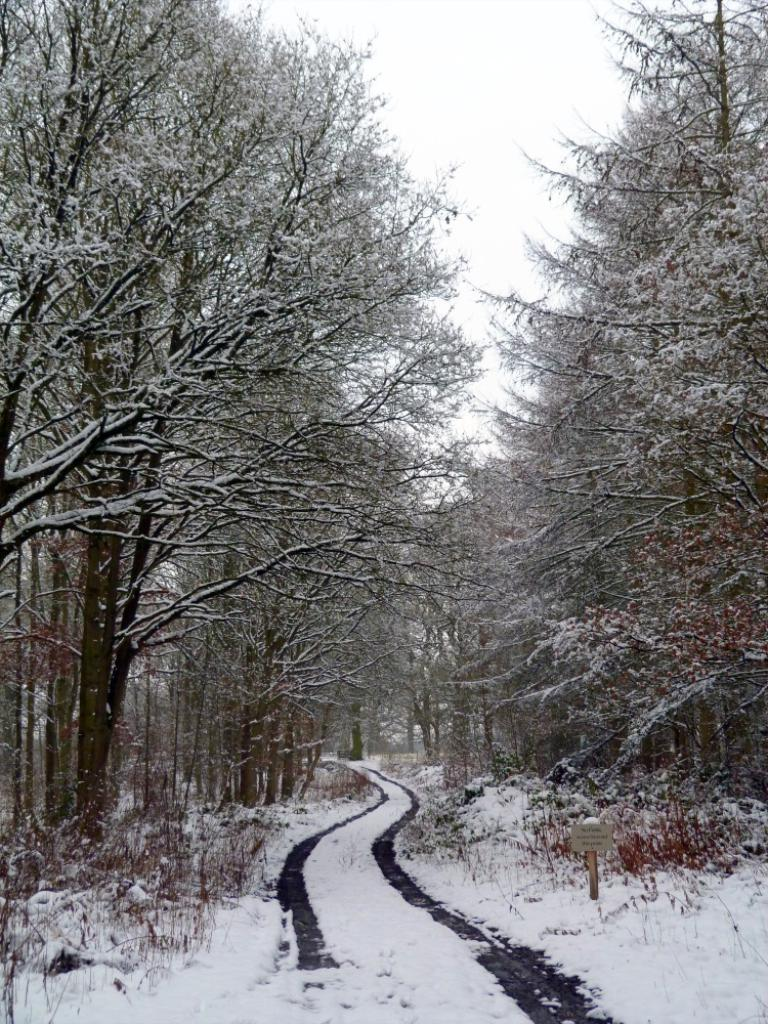What is the main feature of the image? There is a road in the image. What is the condition of the road? Snow is present on the road. What other elements can be seen in the image? There are trees and the sky visible in the image. How would you describe the sky in the image? The sky is cloudy in the image. What type of corn can be seen growing on the side of the road in the image? There is no corn present in the image; it features a road with snow and trees. 